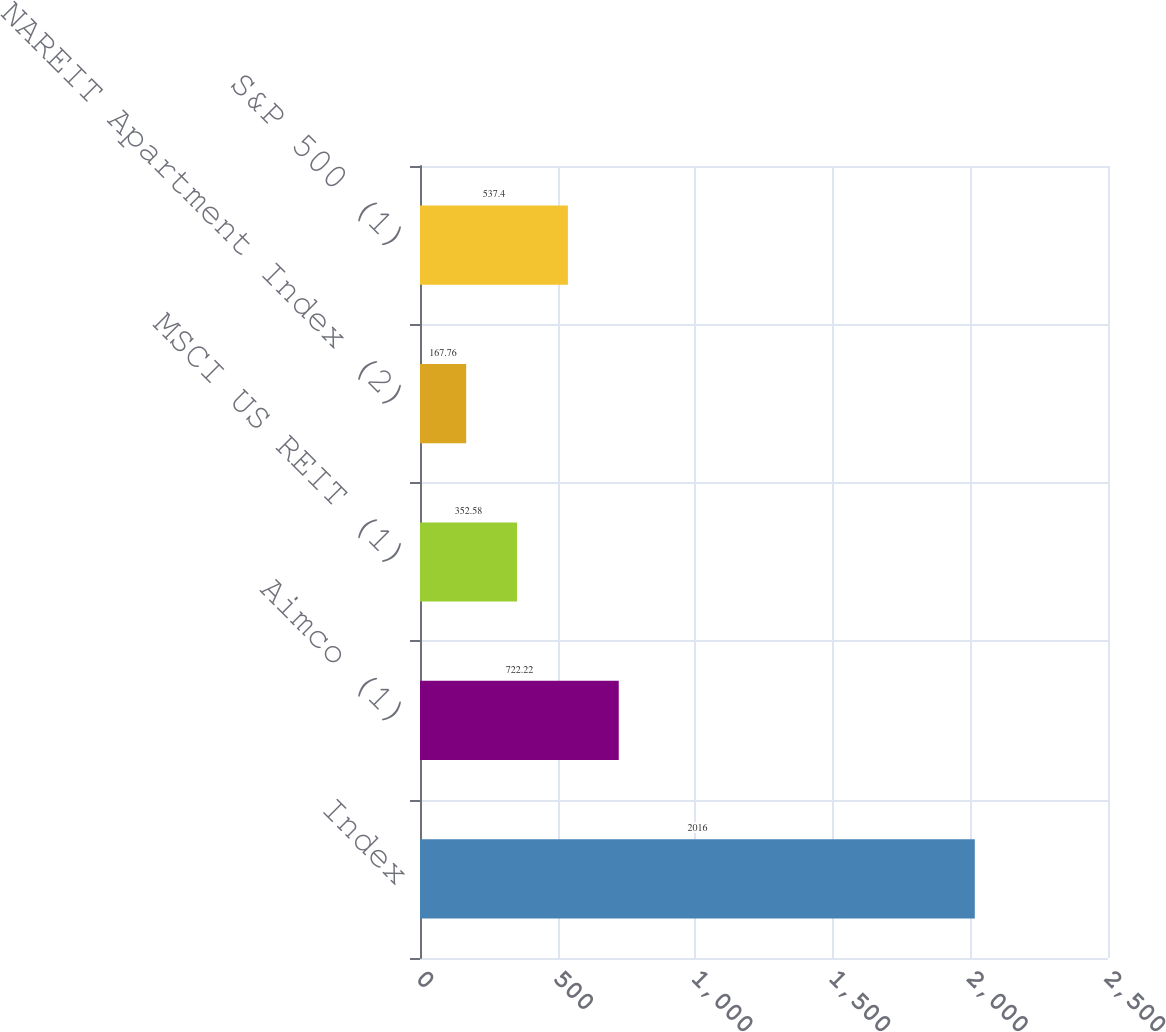<chart> <loc_0><loc_0><loc_500><loc_500><bar_chart><fcel>Index<fcel>Aimco (1)<fcel>MSCI US REIT (1)<fcel>NAREIT Apartment Index (2)<fcel>S&P 500 (1)<nl><fcel>2016<fcel>722.22<fcel>352.58<fcel>167.76<fcel>537.4<nl></chart> 